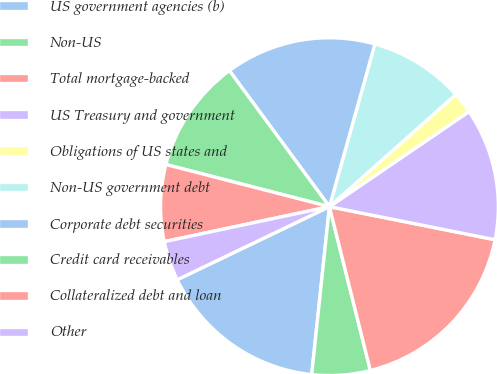Convert chart to OTSL. <chart><loc_0><loc_0><loc_500><loc_500><pie_chart><fcel>US government agencies (b)<fcel>Non-US<fcel>Total mortgage-backed<fcel>US Treasury and government<fcel>Obligations of US states and<fcel>Non-US government debt<fcel>Corporate debt securities<fcel>Credit card receivables<fcel>Collateralized debt and loan<fcel>Other<nl><fcel>16.2%<fcel>5.57%<fcel>17.97%<fcel>12.66%<fcel>2.03%<fcel>9.11%<fcel>14.43%<fcel>10.89%<fcel>7.34%<fcel>3.8%<nl></chart> 